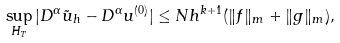<formula> <loc_0><loc_0><loc_500><loc_500>\sup _ { H _ { T } } | D ^ { \alpha } \tilde { u } _ { h } - D ^ { \alpha } u ^ { ( 0 ) } | \leq N h ^ { k + 1 } ( \| f \| _ { m } + \| g \| _ { m } ) ,</formula> 